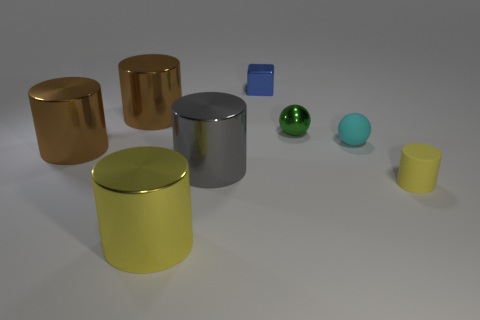Subtract all purple spheres. How many yellow cylinders are left? 2 Subtract all big gray metal cylinders. How many cylinders are left? 4 Add 1 green objects. How many objects exist? 9 Subtract all gray cylinders. How many cylinders are left? 4 Subtract all cylinders. How many objects are left? 3 Subtract 0 gray blocks. How many objects are left? 8 Subtract all gray cylinders. Subtract all red cubes. How many cylinders are left? 4 Subtract all tiny red blocks. Subtract all small green shiny things. How many objects are left? 7 Add 1 big metal objects. How many big metal objects are left? 5 Add 4 large yellow matte spheres. How many large yellow matte spheres exist? 4 